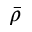Convert formula to latex. <formula><loc_0><loc_0><loc_500><loc_500>\bar { \rho }</formula> 